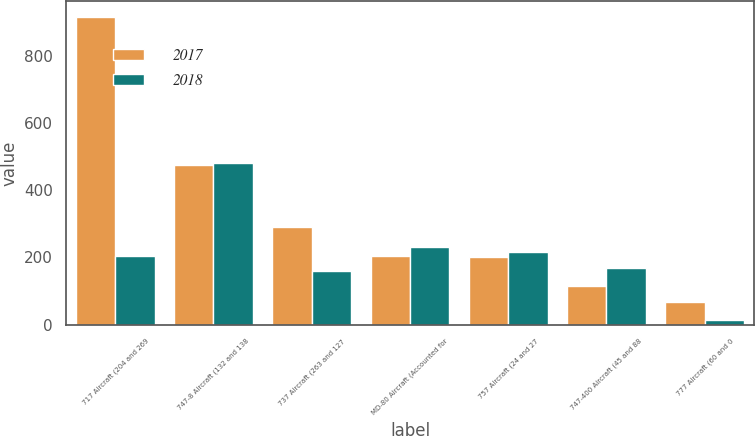<chart> <loc_0><loc_0><loc_500><loc_500><stacked_bar_chart><ecel><fcel>717 Aircraft (204 and 269<fcel>747-8 Aircraft (132 and 138<fcel>737 Aircraft (263 and 127<fcel>MD-80 Aircraft (Accounted for<fcel>757 Aircraft (24 and 27<fcel>747-400 Aircraft (45 and 88<fcel>777 Aircraft (60 and 0<nl><fcel>2017<fcel>918<fcel>477<fcel>290<fcel>204<fcel>200<fcel>116<fcel>68<nl><fcel>2018<fcel>204<fcel>483<fcel>161<fcel>231<fcel>217<fcel>170<fcel>14<nl></chart> 